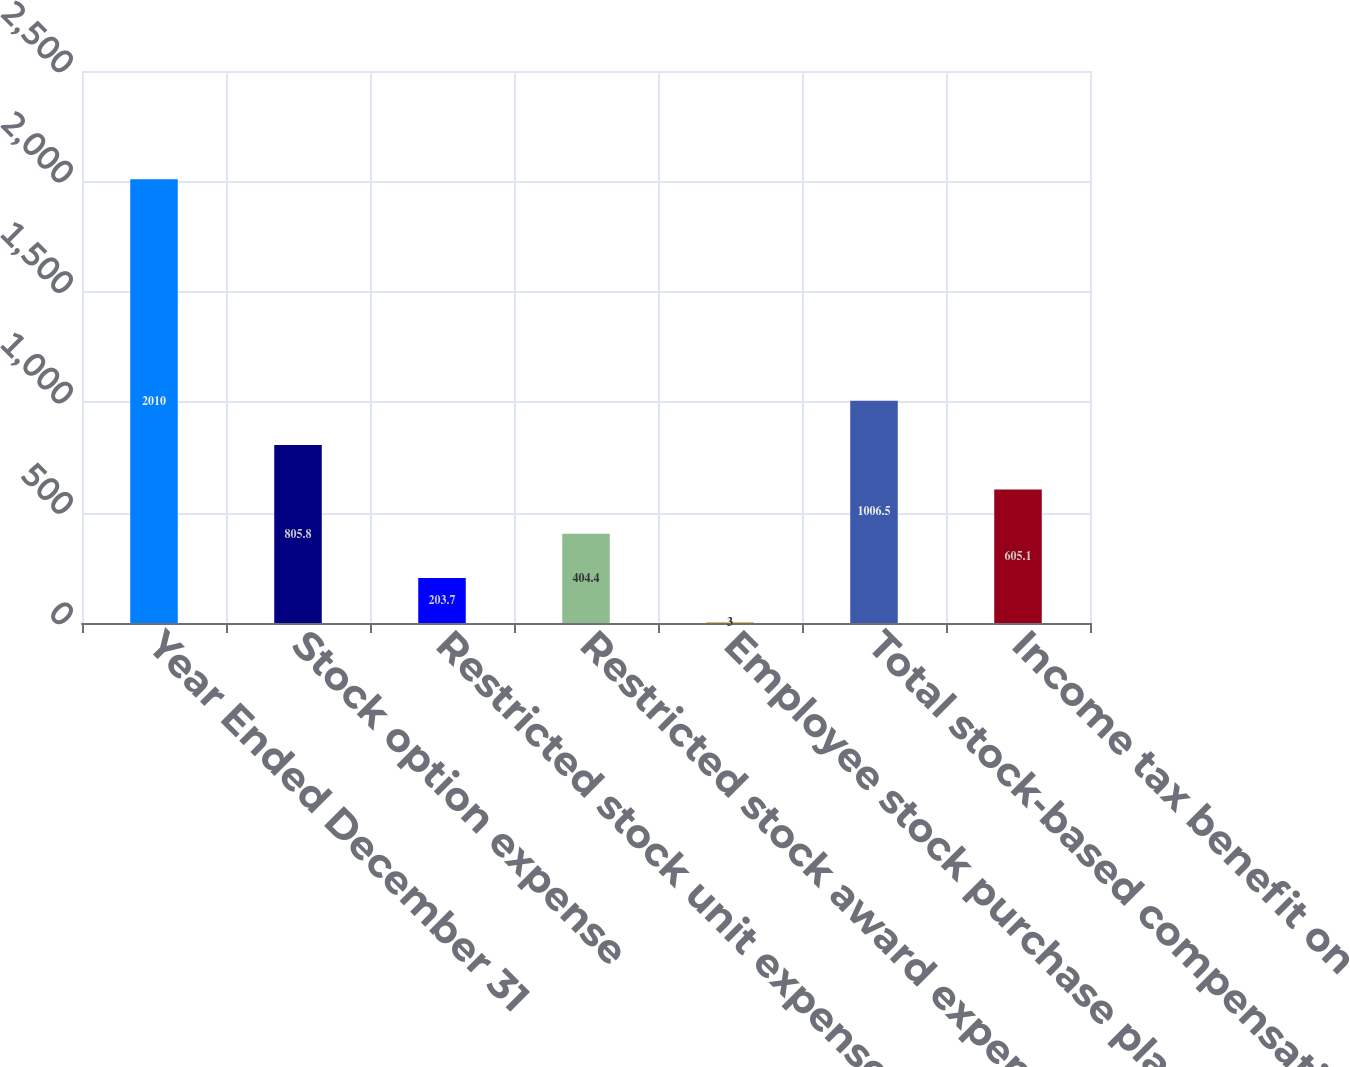Convert chart to OTSL. <chart><loc_0><loc_0><loc_500><loc_500><bar_chart><fcel>Year Ended December 31<fcel>Stock option expense<fcel>Restricted stock unit expense<fcel>Restricted stock award expense<fcel>Employee stock purchase plan<fcel>Total stock-based compensation<fcel>Income tax benefit on<nl><fcel>2010<fcel>805.8<fcel>203.7<fcel>404.4<fcel>3<fcel>1006.5<fcel>605.1<nl></chart> 